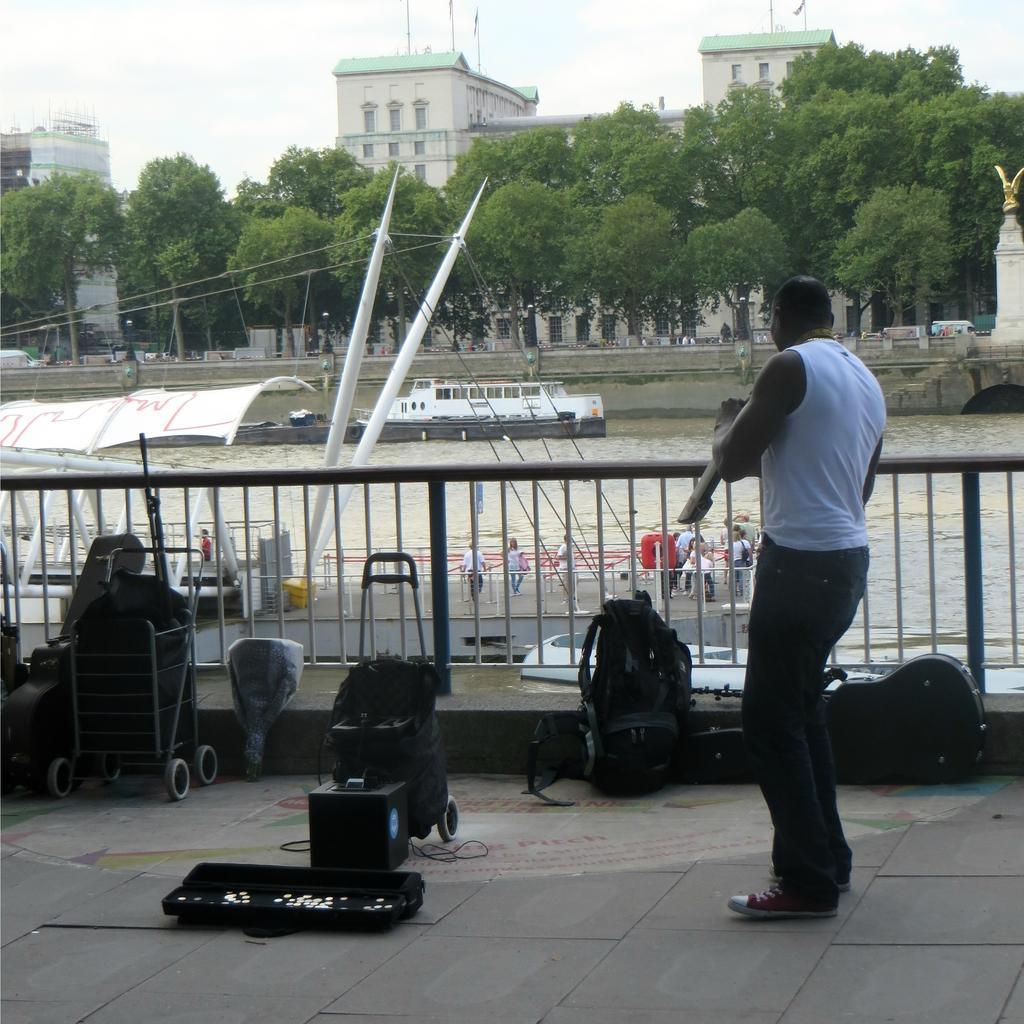Can you describe this image briefly? At the bottom of the image on the floor there is a man standing. And also there are bags, strollers and some other things. Behind them there is railing. Behind the railing there are few people standing on wooden deck with roof. And on the water there is a ship. Above the water there is a bridge. Behind the water there are trees and poles. Behind them there are buildings. At the top of the image there is sky. 